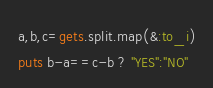Convert code to text. <code><loc_0><loc_0><loc_500><loc_500><_Ruby_>a,b,c=gets.split.map(&:to_i)
puts b-a==c-b ? "YES":"NO"
</code> 